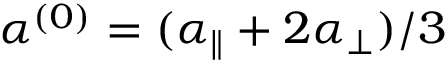Convert formula to latex. <formula><loc_0><loc_0><loc_500><loc_500>\alpha ^ { ( 0 ) } = ( \alpha _ { \| } + 2 \alpha _ { \perp } ) / 3</formula> 